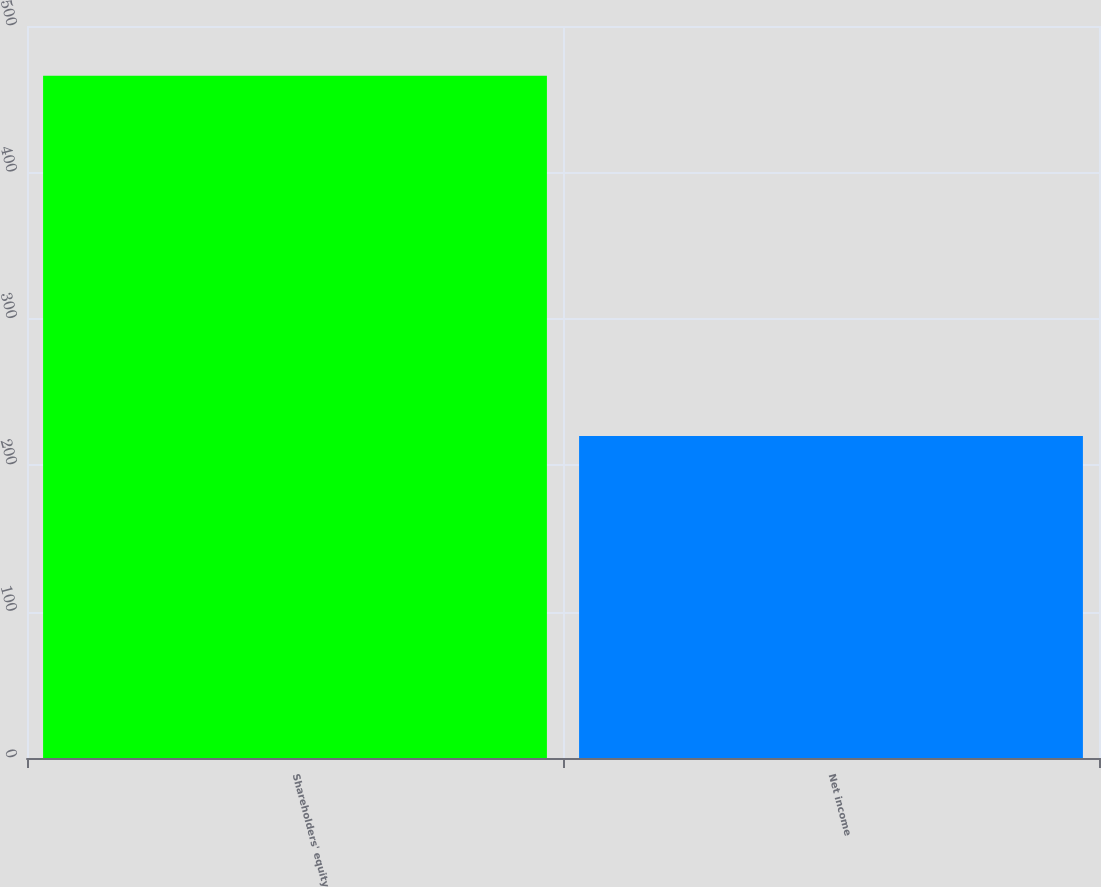Convert chart to OTSL. <chart><loc_0><loc_0><loc_500><loc_500><bar_chart><fcel>Shareholders' equity<fcel>Net income<nl><fcel>466<fcel>220<nl></chart> 